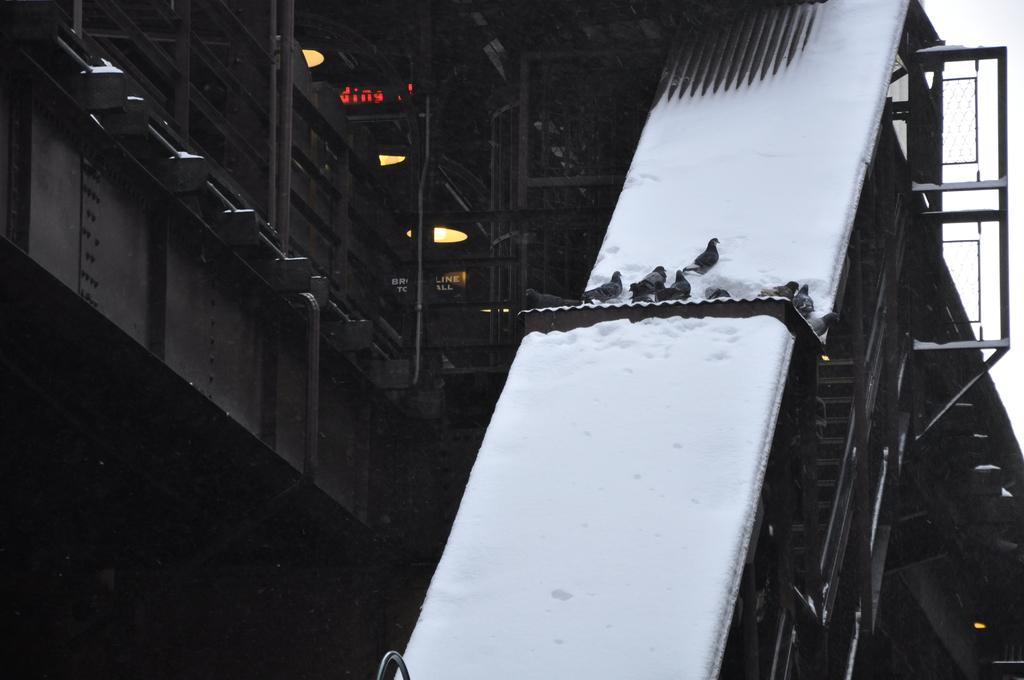What type of structure is visible in the image? There is a building in the image. What decorative elements are present on the building? The building has stars on it. What is covering the roof of the building? The roof is covered with snow. Are there any living creatures visible in the image? Yes, there are birds in the image. What type of locket can be seen hanging from the roof of the building? There is no locket present on the roof of the building in the image. How many circles can be seen on the building? The provided facts do not mention any circles on the building, so it cannot be determined from the image. 